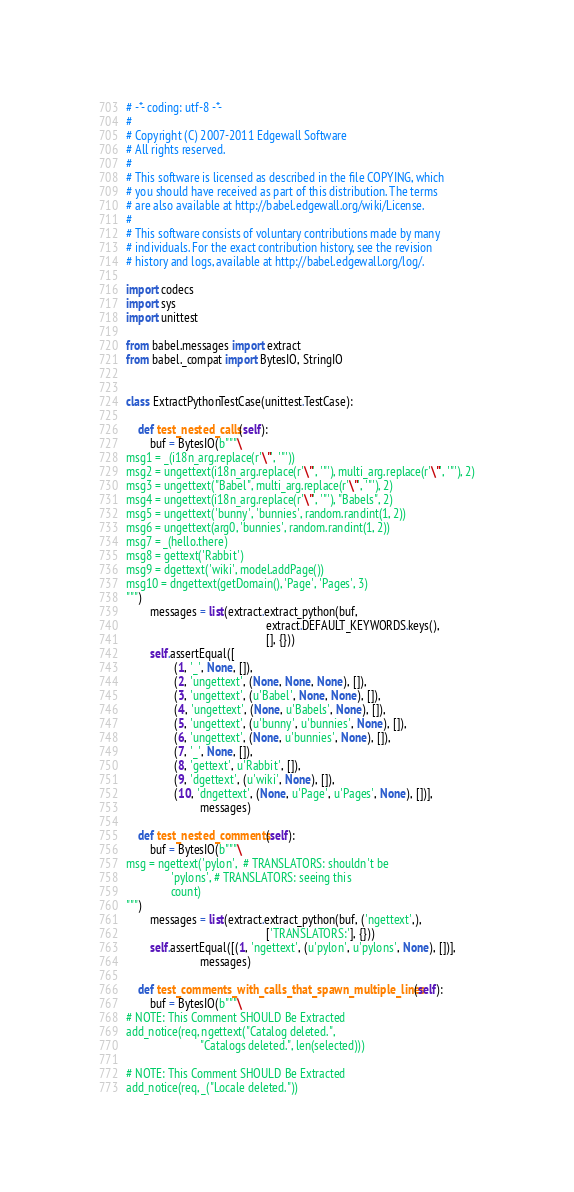<code> <loc_0><loc_0><loc_500><loc_500><_Python_># -*- coding: utf-8 -*-
#
# Copyright (C) 2007-2011 Edgewall Software
# All rights reserved.
#
# This software is licensed as described in the file COPYING, which
# you should have received as part of this distribution. The terms
# are also available at http://babel.edgewall.org/wiki/License.
#
# This software consists of voluntary contributions made by many
# individuals. For the exact contribution history, see the revision
# history and logs, available at http://babel.edgewall.org/log/.

import codecs
import sys
import unittest

from babel.messages import extract
from babel._compat import BytesIO, StringIO


class ExtractPythonTestCase(unittest.TestCase):

    def test_nested_calls(self):
        buf = BytesIO(b"""\
msg1 = _(i18n_arg.replace(r'\"', '"'))
msg2 = ungettext(i18n_arg.replace(r'\"', '"'), multi_arg.replace(r'\"', '"'), 2)
msg3 = ungettext("Babel", multi_arg.replace(r'\"', '"'), 2)
msg4 = ungettext(i18n_arg.replace(r'\"', '"'), "Babels", 2)
msg5 = ungettext('bunny', 'bunnies', random.randint(1, 2))
msg6 = ungettext(arg0, 'bunnies', random.randint(1, 2))
msg7 = _(hello.there)
msg8 = gettext('Rabbit')
msg9 = dgettext('wiki', model.addPage())
msg10 = dngettext(getDomain(), 'Page', 'Pages', 3)
""")
        messages = list(extract.extract_python(buf,
                                               extract.DEFAULT_KEYWORDS.keys(),
                                               [], {}))
        self.assertEqual([
                (1, '_', None, []),
                (2, 'ungettext', (None, None, None), []),
                (3, 'ungettext', (u'Babel', None, None), []),
                (4, 'ungettext', (None, u'Babels', None), []),
                (5, 'ungettext', (u'bunny', u'bunnies', None), []),
                (6, 'ungettext', (None, u'bunnies', None), []),
                (7, '_', None, []),
                (8, 'gettext', u'Rabbit', []),
                (9, 'dgettext', (u'wiki', None), []),
                (10, 'dngettext', (None, u'Page', u'Pages', None), [])],
                         messages)

    def test_nested_comments(self):
        buf = BytesIO(b"""\
msg = ngettext('pylon',  # TRANSLATORS: shouldn't be
               'pylons', # TRANSLATORS: seeing this
               count)
""")
        messages = list(extract.extract_python(buf, ('ngettext',),
                                               ['TRANSLATORS:'], {}))
        self.assertEqual([(1, 'ngettext', (u'pylon', u'pylons', None), [])],
                         messages)

    def test_comments_with_calls_that_spawn_multiple_lines(self):
        buf = BytesIO(b"""\
# NOTE: This Comment SHOULD Be Extracted
add_notice(req, ngettext("Catalog deleted.",
                         "Catalogs deleted.", len(selected)))

# NOTE: This Comment SHOULD Be Extracted
add_notice(req, _("Locale deleted."))

</code> 